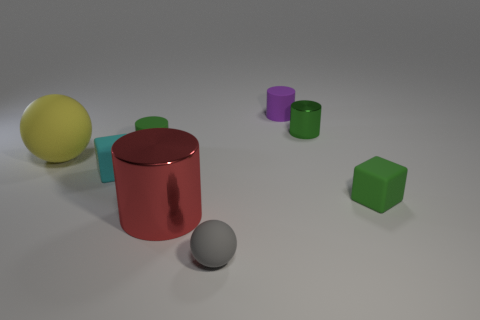What number of gray things are metal objects or big objects?
Offer a very short reply. 0. What number of other things are the same shape as the red metal object?
Offer a terse response. 3. What is the shape of the thing that is right of the large cylinder and to the left of the purple matte cylinder?
Offer a very short reply. Sphere. There is a tiny purple rubber cylinder; are there any gray spheres on the right side of it?
Offer a very short reply. No. There is another matte thing that is the same shape as the yellow rubber thing; what size is it?
Offer a very short reply. Small. Is there anything else that has the same size as the red thing?
Ensure brevity in your answer.  Yes. Do the yellow object and the small purple object have the same shape?
Provide a succinct answer. No. How big is the green matte cylinder that is in front of the tiny matte cylinder on the right side of the tiny green matte cylinder?
Your answer should be very brief. Small. There is another metallic object that is the same shape as the red thing; what color is it?
Provide a succinct answer. Green. What number of cubes are the same color as the tiny metallic thing?
Offer a terse response. 1. 